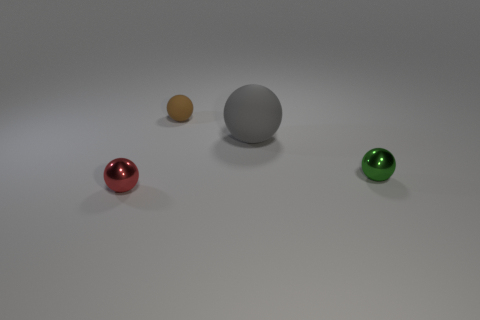What materials do the colored objects seem to be made of, and what could be their function? The colored objects have a shiny appearance, which suggests they could be made of a polished metal or plastic with a reflective surface. Their function isn't clear from the image alone, but they might be decorative elements or part of a set of objects used in a game or educational activity to teach colors and shapes. 